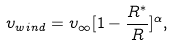Convert formula to latex. <formula><loc_0><loc_0><loc_500><loc_500>\upsilon _ { w i n d } = \upsilon _ { \infty } [ 1 - \frac { R ^ { * } } { R } ] ^ { \alpha } ,</formula> 